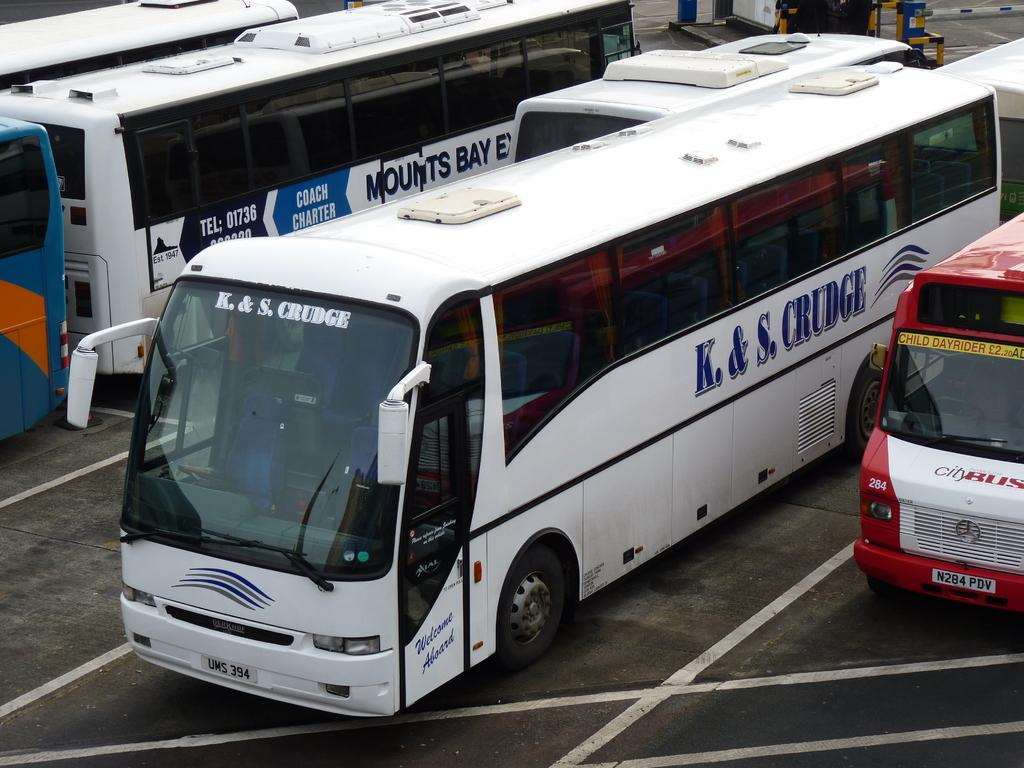<image>
Create a compact narrative representing the image presented. A K. & S. Crudge charter bus is parket next to other charter buses. 